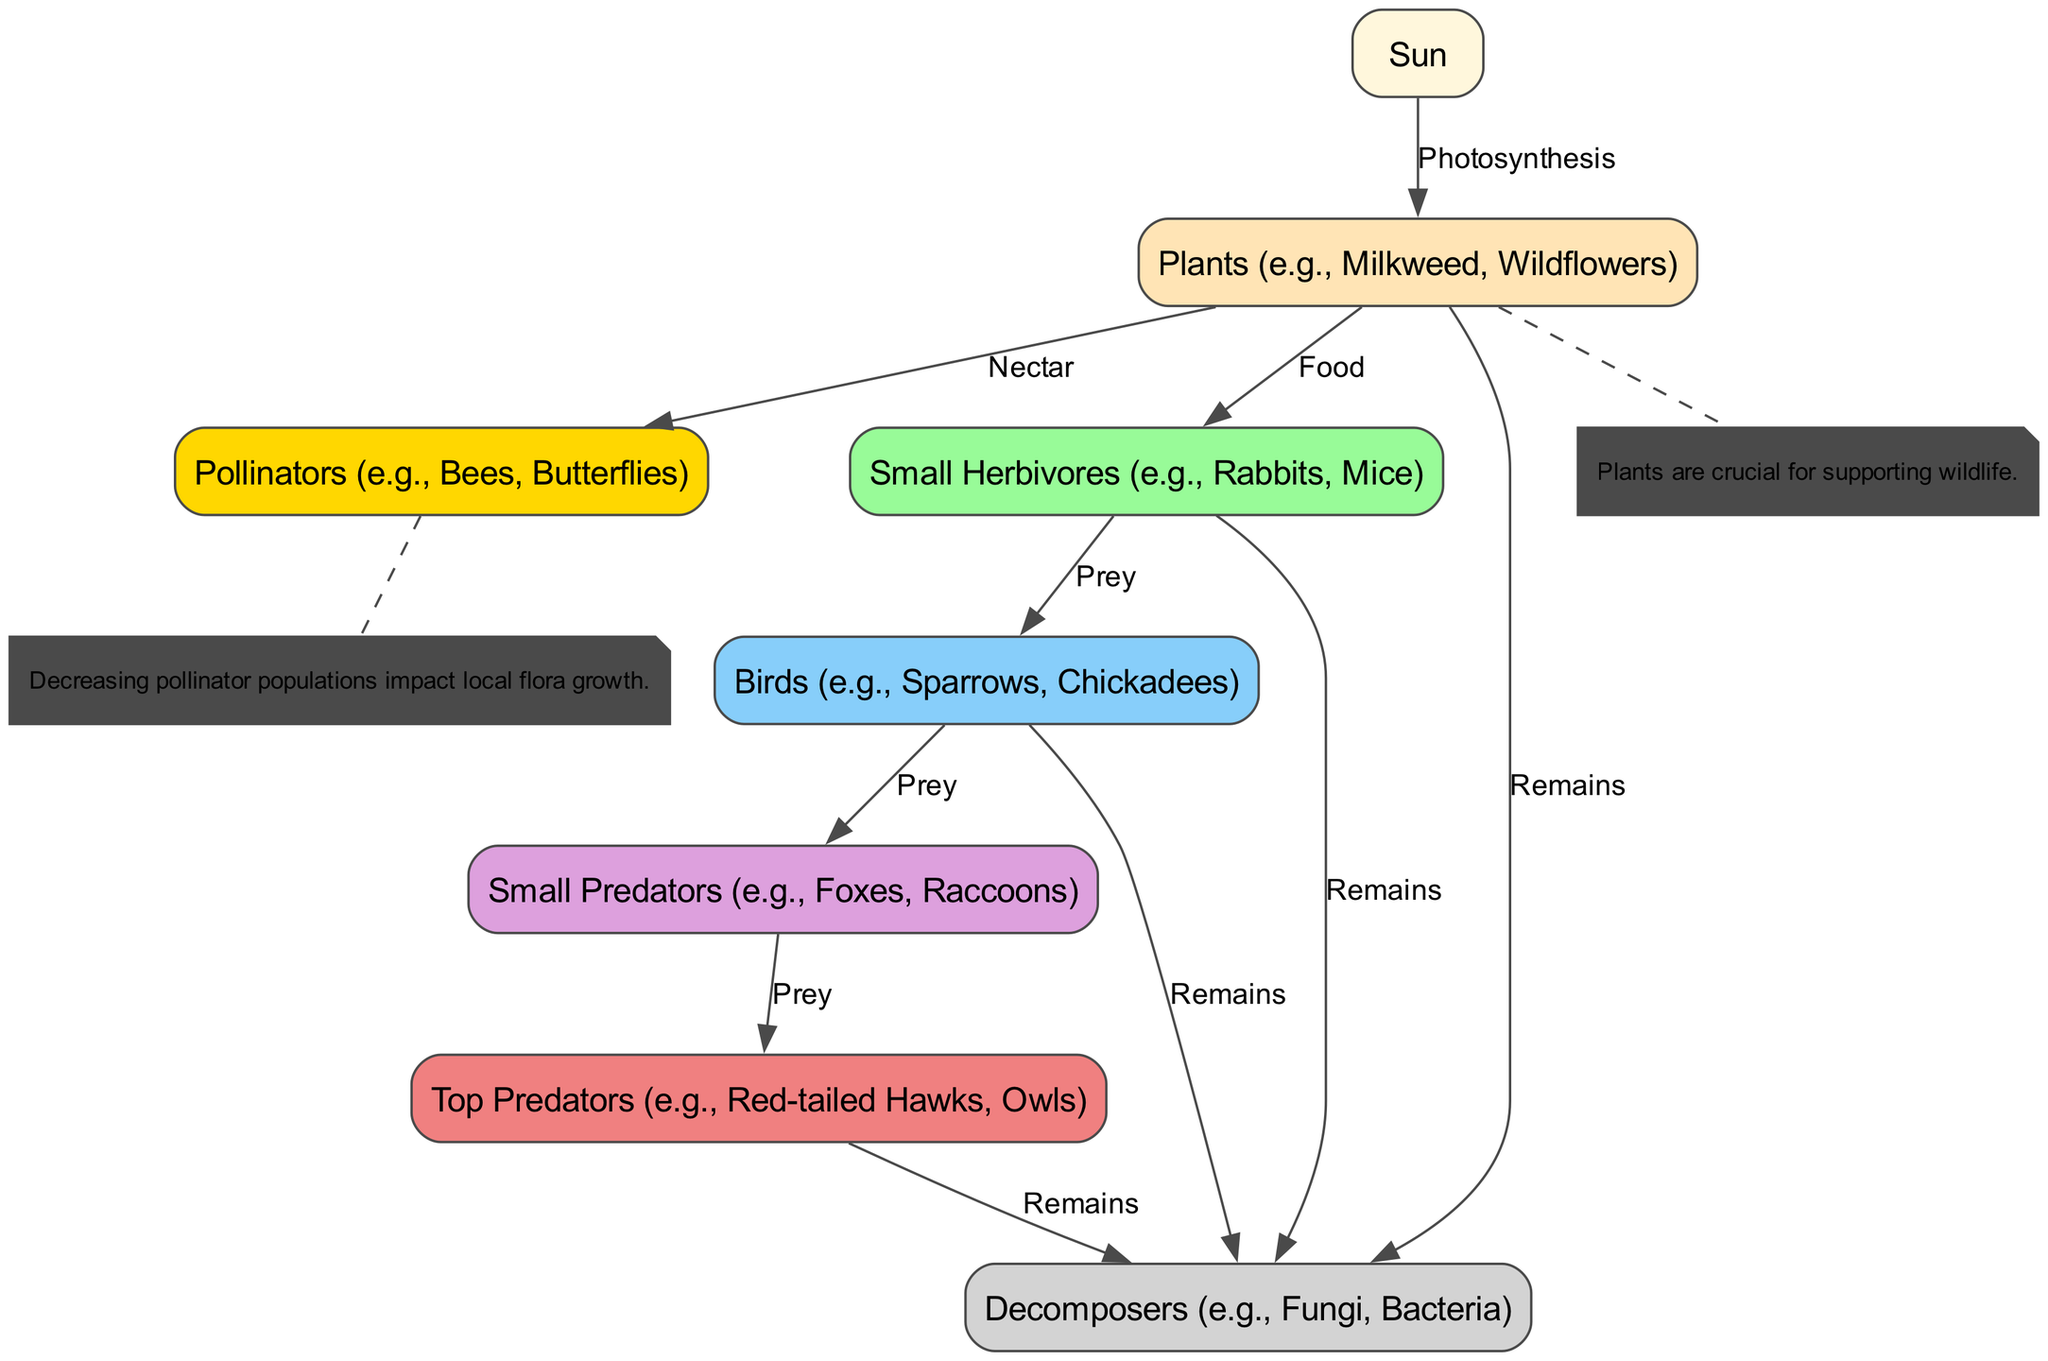What is the energy source for plants in this food web? The food web starts with the Sun, which is identified as the source of energy for plants. This relationship is represented by the edge labeled "Photosynthesis" connecting the Sun to the Plants node.
Answer: Sun Which animals depend on plants for food? The diagram shows arrows leading from the Plants node to Small Herbivores, indicating that they feed on these plants. Additionally, the edge from Plants to the Pollinators indicates that pollinators also utilize plants, but primarily for nectar.
Answer: Small Herbivores, Pollinators How many predatory levels are represented in the food web? The food web includes Small Predators, Top Predators, and their corresponding prey. We see Small Predators linking to Top Predators, indicating a second level of predation, while under that we have Small Herbivores being preyed on by Birds as a first level. Therefore, there are two levels of predatory relationships.
Answer: Two What impacts local flora growth according to the annotations? The annotation tied to the Pollinators node states that decreasing pollinator populations impact local flora growth. This highlights the importance of pollinators like bees and butterflies for the health of plant life.
Answer: Decreasing pollinator populations What is the relationship between top predators and decomposers? The diagram shows that Top Predators are connected to Decomposers via an edge labeled "Remains." This indicates a relationship where the remains of top predators contribute to the decomposer's processes, signifying a return of nutrients to the ecosystem.
Answer: Remains How many nodes are there in total? The diagram includes eight distinct nodes representing different elements of the food web, including the Sun, Plants, Pollinators, Small Herbivores, Birds, Small Predators, Top Predators, and Decomposers. Counting these nodes gives us the total number of unique components in the food web.
Answer: Eight What type of interaction occurs between pollinators and plants? The interaction between Pollinators and Plants is defined by the edge labeled "Nectar," indicating that pollinators consume nectar from the plants, which is essential for their survival and contributes to pollination.
Answer: Nectar Which group indirectly supports the small predators in the ecosystem? The Small Herbivores serve as a food source for Small Predators. Since the relationship is established through a "Prey" connection, it signifies that small predators depend on herbivores to complete their life cycle indirectly.
Answer: Small Herbivores 